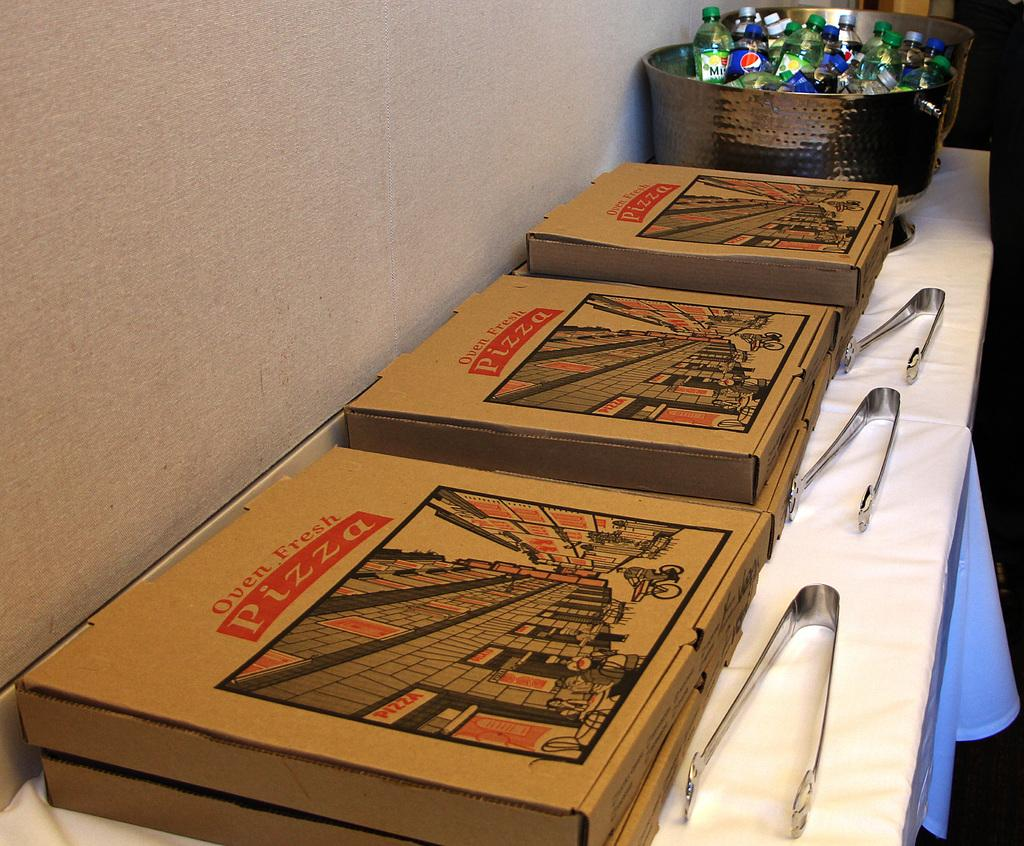<image>
Offer a succinct explanation of the picture presented. Boxes of Ozen Fresh Pizza and a basket filled with soft drinks on a buffet table 